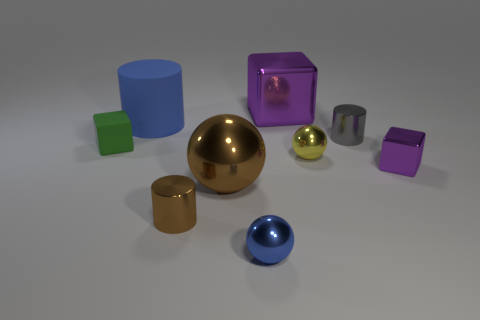Are there any tiny shiny blocks that have the same color as the big metal cube?
Your answer should be very brief. Yes. Is the color of the large metallic sphere the same as the small metal cylinder in front of the tiny yellow metallic object?
Your answer should be very brief. Yes. There is a tiny metallic object that is the same color as the big cube; what shape is it?
Keep it short and to the point. Cube. Is the small block on the right side of the blue metallic ball made of the same material as the large purple thing?
Your response must be concise. Yes. How many other things are the same size as the brown metallic sphere?
Give a very brief answer. 2. What number of small things are cubes or gray things?
Offer a terse response. 3. Does the tiny shiny block have the same color as the big metal cube?
Your answer should be very brief. Yes. Are there more purple blocks left of the small gray shiny thing than yellow balls that are to the left of the large matte cylinder?
Provide a short and direct response. Yes. There is a metal thing to the left of the brown sphere; does it have the same color as the big metal sphere?
Provide a short and direct response. Yes. Is there any other thing that has the same color as the big metal sphere?
Offer a very short reply. Yes. 